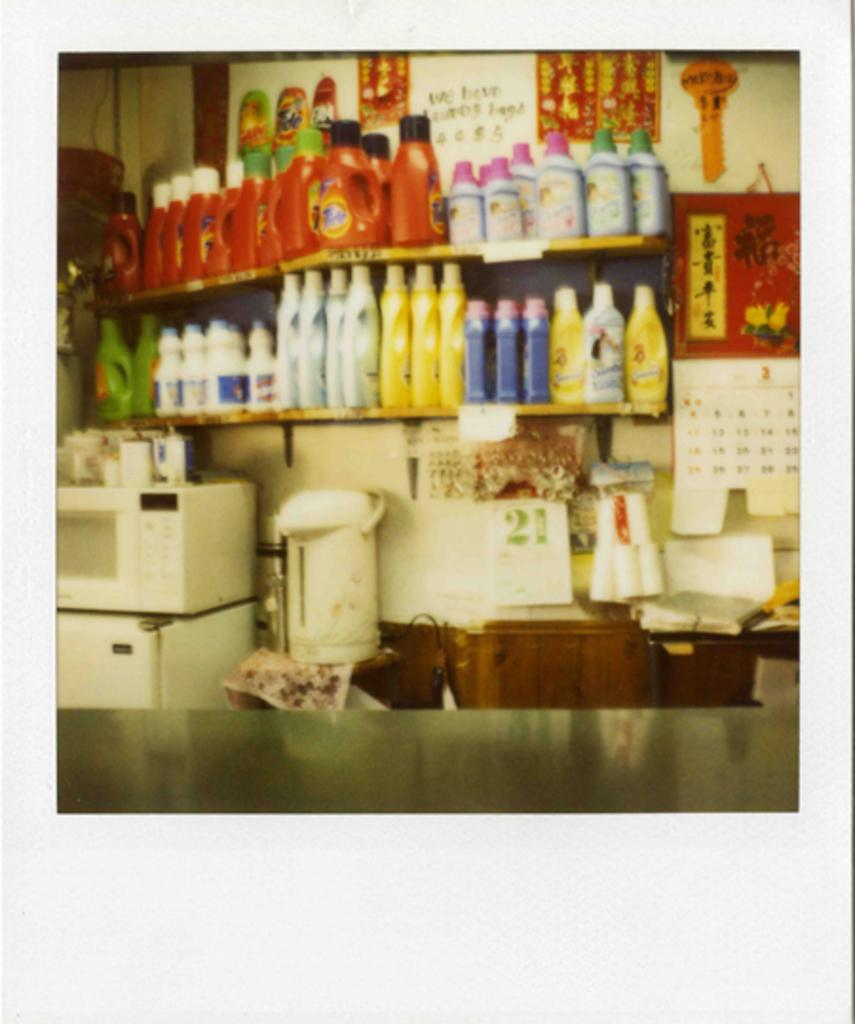<image>
Describe the image concisely. A shelf of bottles with a calendar bearing the number 21 on it. 